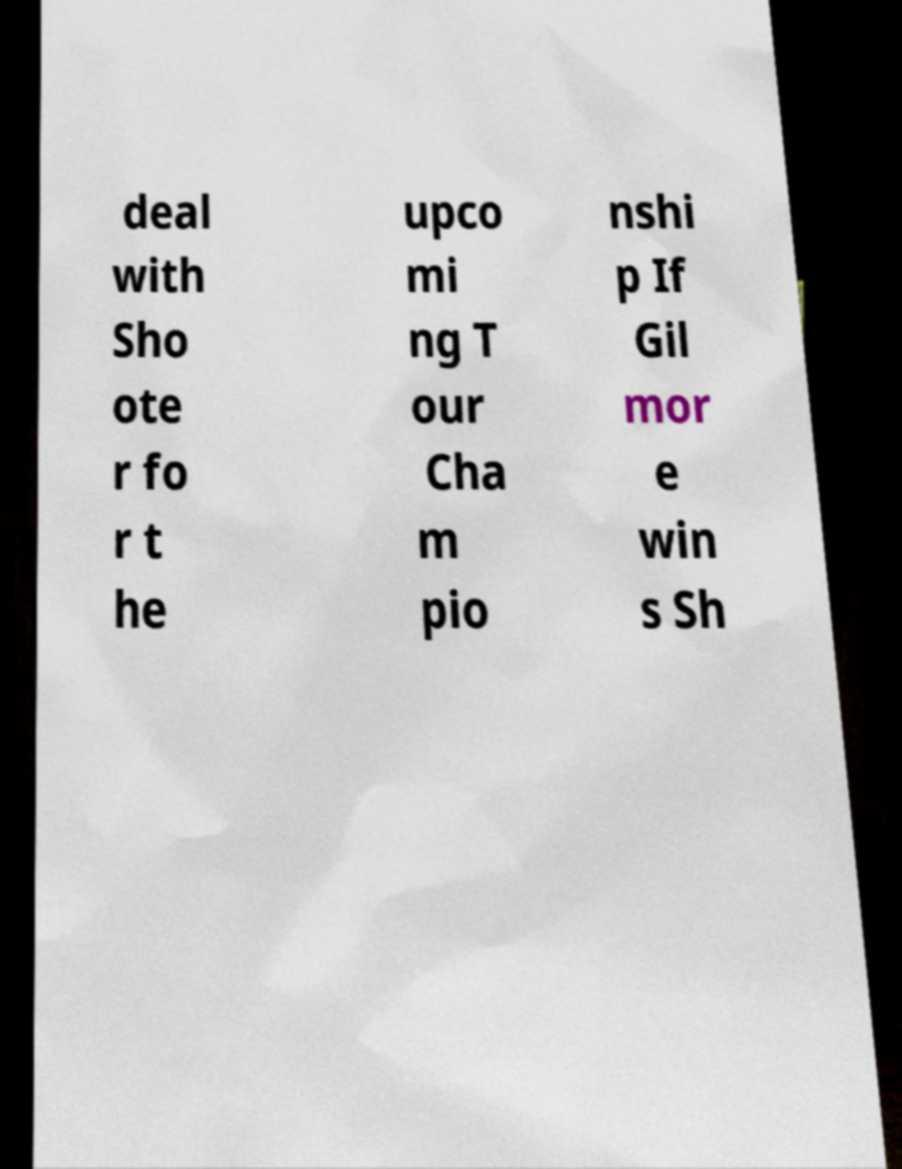I need the written content from this picture converted into text. Can you do that? deal with Sho ote r fo r t he upco mi ng T our Cha m pio nshi p If Gil mor e win s Sh 